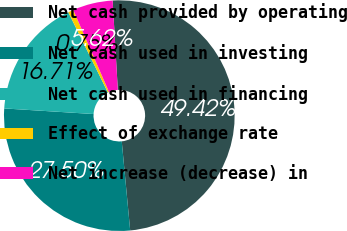Convert chart to OTSL. <chart><loc_0><loc_0><loc_500><loc_500><pie_chart><fcel>Net cash provided by operating<fcel>Net cash used in investing<fcel>Net cash used in financing<fcel>Effect of exchange rate<fcel>Net increase (decrease) in<nl><fcel>49.42%<fcel>27.5%<fcel>16.71%<fcel>0.75%<fcel>5.62%<nl></chart> 